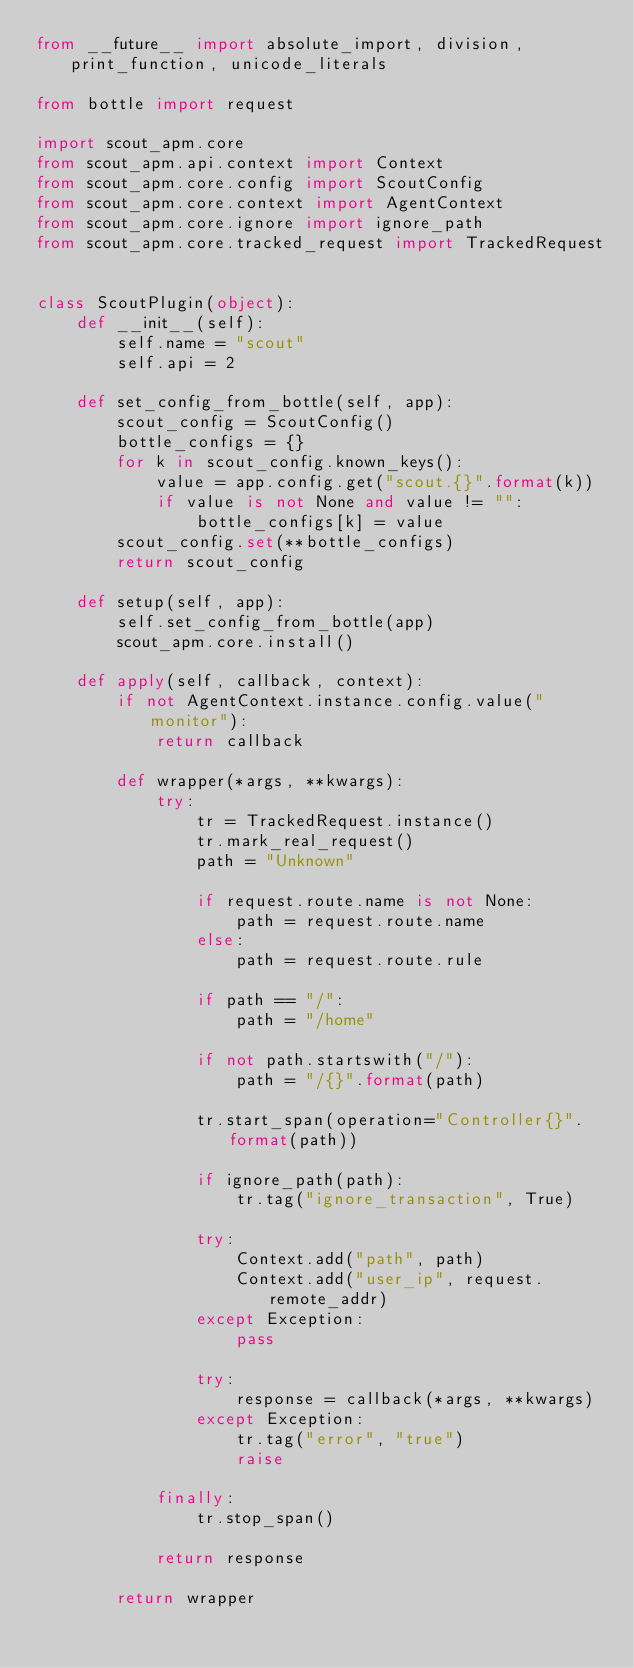<code> <loc_0><loc_0><loc_500><loc_500><_Python_>from __future__ import absolute_import, division, print_function, unicode_literals

from bottle import request

import scout_apm.core
from scout_apm.api.context import Context
from scout_apm.core.config import ScoutConfig
from scout_apm.core.context import AgentContext
from scout_apm.core.ignore import ignore_path
from scout_apm.core.tracked_request import TrackedRequest


class ScoutPlugin(object):
    def __init__(self):
        self.name = "scout"
        self.api = 2

    def set_config_from_bottle(self, app):
        scout_config = ScoutConfig()
        bottle_configs = {}
        for k in scout_config.known_keys():
            value = app.config.get("scout.{}".format(k))
            if value is not None and value != "":
                bottle_configs[k] = value
        scout_config.set(**bottle_configs)
        return scout_config

    def setup(self, app):
        self.set_config_from_bottle(app)
        scout_apm.core.install()

    def apply(self, callback, context):
        if not AgentContext.instance.config.value("monitor"):
            return callback

        def wrapper(*args, **kwargs):
            try:
                tr = TrackedRequest.instance()
                tr.mark_real_request()
                path = "Unknown"

                if request.route.name is not None:
                    path = request.route.name
                else:
                    path = request.route.rule

                if path == "/":
                    path = "/home"

                if not path.startswith("/"):
                    path = "/{}".format(path)

                tr.start_span(operation="Controller{}".format(path))

                if ignore_path(path):
                    tr.tag("ignore_transaction", True)

                try:
                    Context.add("path", path)
                    Context.add("user_ip", request.remote_addr)
                except Exception:
                    pass

                try:
                    response = callback(*args, **kwargs)
                except Exception:
                    tr.tag("error", "true")
                    raise

            finally:
                tr.stop_span()

            return response

        return wrapper
</code> 